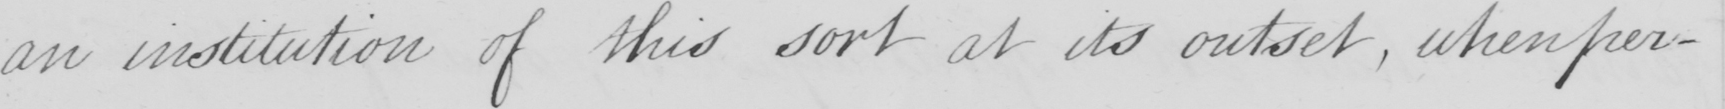Can you read and transcribe this handwriting? an institution of this sort at its outset , when per- 